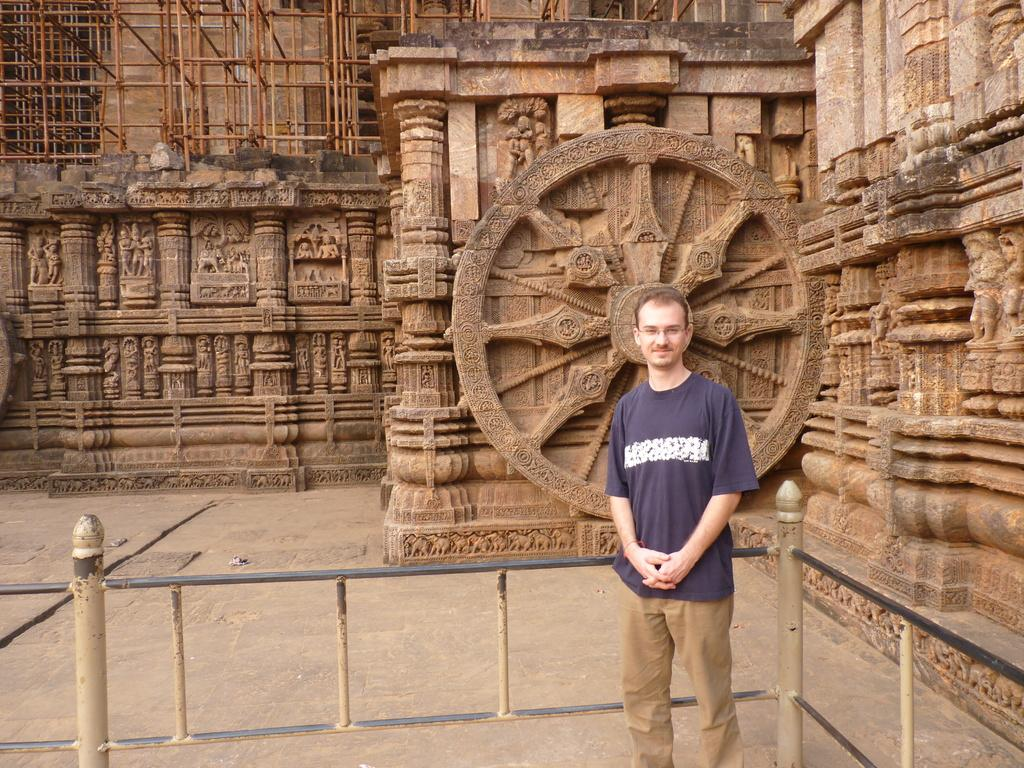What is the main subject of the image? There is a man in the image. What is the man doing in the image? The man is standing. What is the man wearing in the image? The man is wearing a blue t-shirt and brown pants. What can be seen behind the man in the image? There is a fence behind the man. What type of location is depicted in the image? There is a historic place in the image. What additional features can be seen at the historic place? There are sculptures present at the historic place. Is there a crack in the man's blue t-shirt in the image? There is no mention of a crack in the man's blue t-shirt in the provided facts, so we cannot determine its presence from the image. Does the man have a partner with him in the image? There is no mention of a partner or any other person in the image, so we cannot determine if the man has a partner with him. 